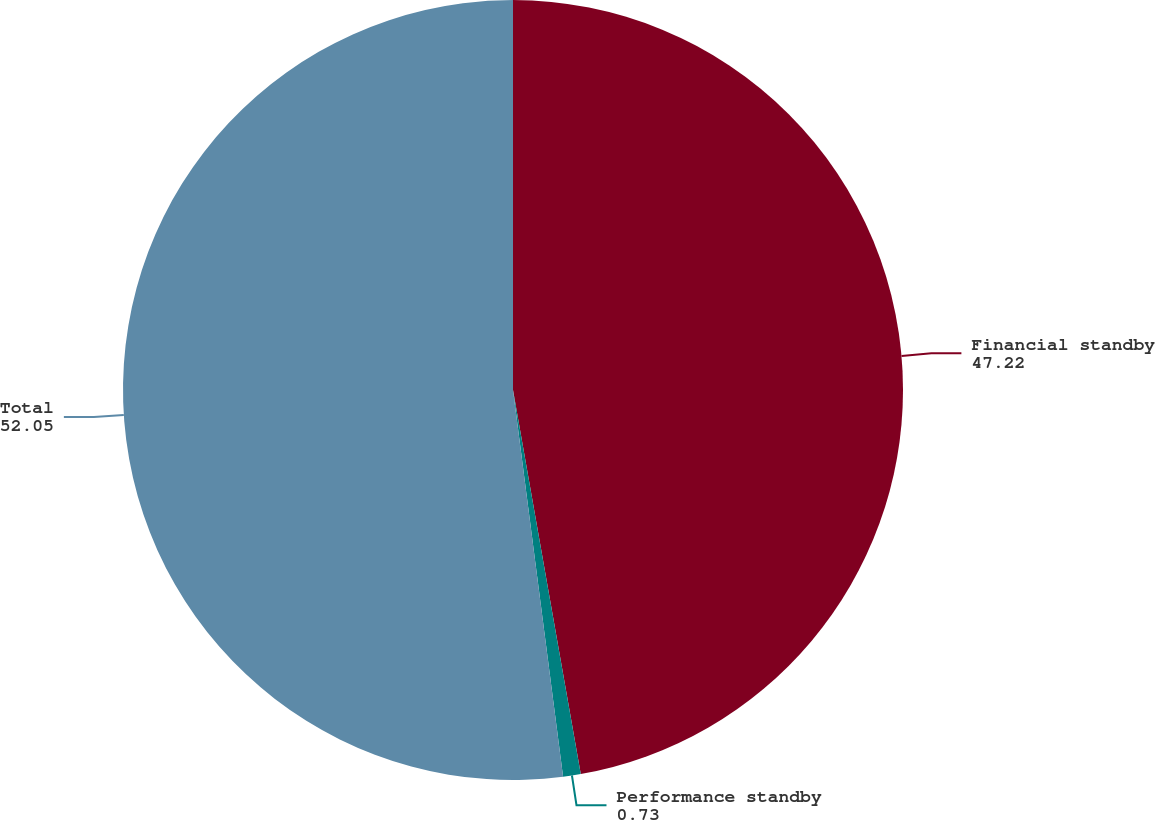Convert chart. <chart><loc_0><loc_0><loc_500><loc_500><pie_chart><fcel>Financial standby<fcel>Performance standby<fcel>Total<nl><fcel>47.22%<fcel>0.73%<fcel>52.05%<nl></chart> 